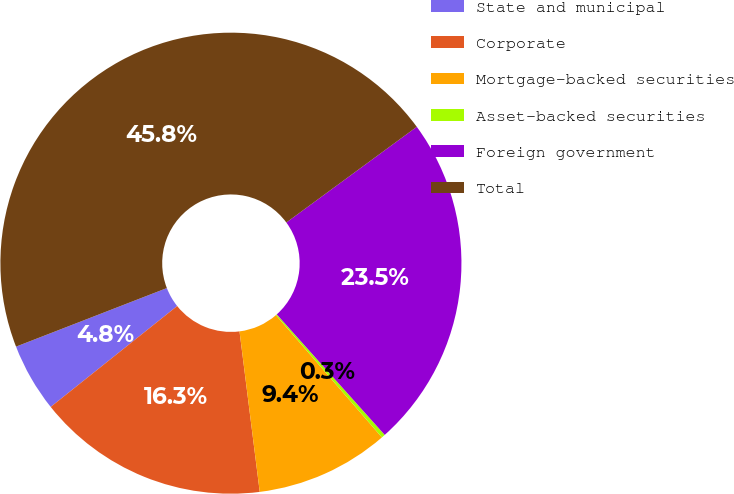<chart> <loc_0><loc_0><loc_500><loc_500><pie_chart><fcel>State and municipal<fcel>Corporate<fcel>Mortgage-backed securities<fcel>Asset-backed securities<fcel>Foreign government<fcel>Total<nl><fcel>4.82%<fcel>16.28%<fcel>9.37%<fcel>0.26%<fcel>23.45%<fcel>45.82%<nl></chart> 